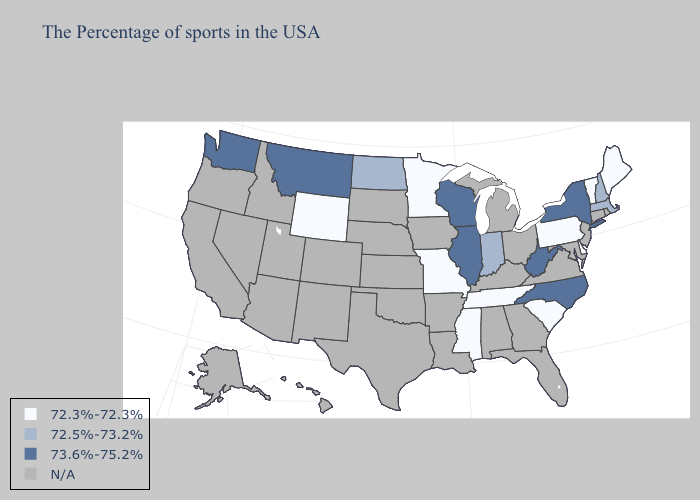Name the states that have a value in the range N/A?
Short answer required. Rhode Island, Connecticut, New Jersey, Maryland, Virginia, Ohio, Florida, Georgia, Michigan, Kentucky, Alabama, Louisiana, Arkansas, Iowa, Kansas, Nebraska, Oklahoma, Texas, South Dakota, Colorado, New Mexico, Utah, Arizona, Idaho, Nevada, California, Oregon, Alaska, Hawaii. Does New Hampshire have the lowest value in the Northeast?
Give a very brief answer. No. Among the states that border Massachusetts , does New York have the lowest value?
Keep it brief. No. Name the states that have a value in the range 72.5%-73.2%?
Be succinct. Massachusetts, New Hampshire, Indiana, North Dakota. Does the map have missing data?
Be succinct. Yes. Is the legend a continuous bar?
Answer briefly. No. What is the value of California?
Keep it brief. N/A. What is the highest value in the South ?
Short answer required. 73.6%-75.2%. Name the states that have a value in the range 72.5%-73.2%?
Be succinct. Massachusetts, New Hampshire, Indiana, North Dakota. Which states have the highest value in the USA?
Concise answer only. New York, North Carolina, West Virginia, Wisconsin, Illinois, Montana, Washington. Among the states that border Maine , which have the lowest value?
Keep it brief. New Hampshire. Is the legend a continuous bar?
Keep it brief. No. What is the lowest value in states that border Minnesota?
Concise answer only. 72.5%-73.2%. Does the map have missing data?
Quick response, please. Yes. 